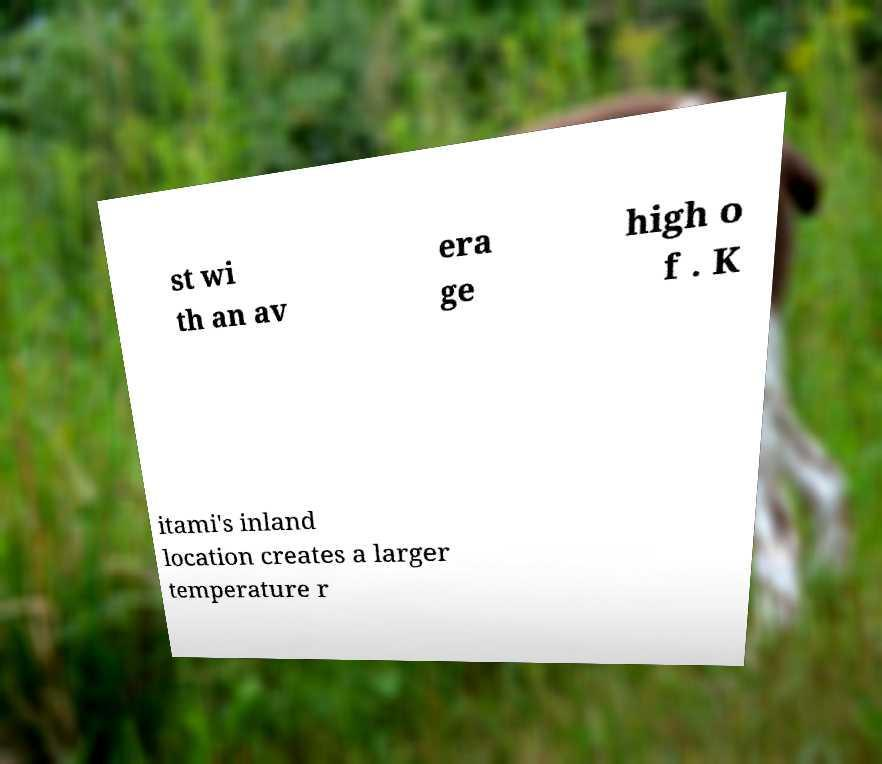Can you read and provide the text displayed in the image?This photo seems to have some interesting text. Can you extract and type it out for me? st wi th an av era ge high o f . K itami's inland location creates a larger temperature r 